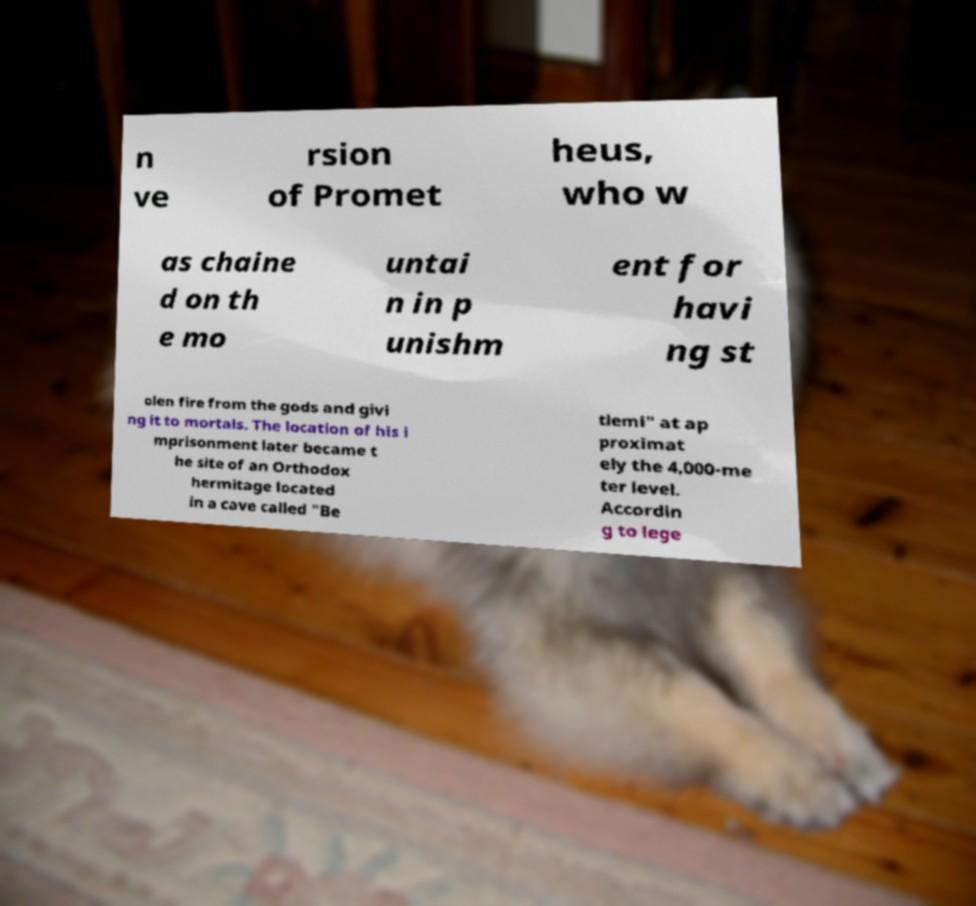Can you read and provide the text displayed in the image?This photo seems to have some interesting text. Can you extract and type it out for me? n ve rsion of Promet heus, who w as chaine d on th e mo untai n in p unishm ent for havi ng st olen fire from the gods and givi ng it to mortals. The location of his i mprisonment later became t he site of an Orthodox hermitage located in a cave called "Be tlemi" at ap proximat ely the 4,000-me ter level. Accordin g to lege 